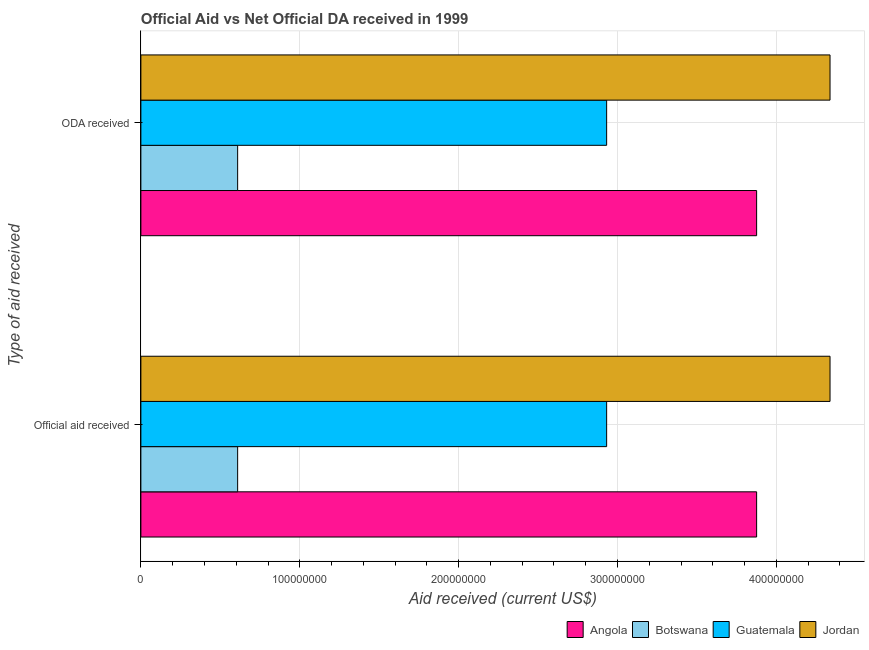How many different coloured bars are there?
Offer a very short reply. 4. How many groups of bars are there?
Make the answer very short. 2. Are the number of bars per tick equal to the number of legend labels?
Offer a terse response. Yes. How many bars are there on the 2nd tick from the top?
Make the answer very short. 4. What is the label of the 1st group of bars from the top?
Offer a very short reply. ODA received. What is the official aid received in Jordan?
Ensure brevity in your answer.  4.34e+08. Across all countries, what is the maximum official aid received?
Your answer should be very brief. 4.34e+08. Across all countries, what is the minimum official aid received?
Offer a terse response. 6.09e+07. In which country was the oda received maximum?
Provide a short and direct response. Jordan. In which country was the official aid received minimum?
Your answer should be very brief. Botswana. What is the total official aid received in the graph?
Keep it short and to the point. 1.18e+09. What is the difference between the oda received in Angola and that in Guatemala?
Your answer should be compact. 9.44e+07. What is the difference between the official aid received in Angola and the oda received in Guatemala?
Your response must be concise. 9.44e+07. What is the average oda received per country?
Your response must be concise. 2.94e+08. What is the difference between the oda received and official aid received in Guatemala?
Give a very brief answer. 0. What is the ratio of the oda received in Guatemala to that in Jordan?
Give a very brief answer. 0.68. Is the official aid received in Angola less than that in Guatemala?
Make the answer very short. No. In how many countries, is the oda received greater than the average oda received taken over all countries?
Provide a succinct answer. 2. What does the 1st bar from the top in ODA received represents?
Offer a very short reply. Jordan. What does the 4th bar from the bottom in Official aid received represents?
Your answer should be very brief. Jordan. How many bars are there?
Ensure brevity in your answer.  8. Are all the bars in the graph horizontal?
Offer a very short reply. Yes. How many countries are there in the graph?
Provide a succinct answer. 4. What is the difference between two consecutive major ticks on the X-axis?
Offer a very short reply. 1.00e+08. Does the graph contain any zero values?
Ensure brevity in your answer.  No. Does the graph contain grids?
Keep it short and to the point. Yes. How are the legend labels stacked?
Make the answer very short. Horizontal. What is the title of the graph?
Ensure brevity in your answer.  Official Aid vs Net Official DA received in 1999 . What is the label or title of the X-axis?
Give a very brief answer. Aid received (current US$). What is the label or title of the Y-axis?
Provide a short and direct response. Type of aid received. What is the Aid received (current US$) in Angola in Official aid received?
Offer a terse response. 3.88e+08. What is the Aid received (current US$) in Botswana in Official aid received?
Offer a terse response. 6.09e+07. What is the Aid received (current US$) in Guatemala in Official aid received?
Offer a terse response. 2.93e+08. What is the Aid received (current US$) of Jordan in Official aid received?
Give a very brief answer. 4.34e+08. What is the Aid received (current US$) in Angola in ODA received?
Provide a succinct answer. 3.88e+08. What is the Aid received (current US$) of Botswana in ODA received?
Your answer should be compact. 6.09e+07. What is the Aid received (current US$) in Guatemala in ODA received?
Make the answer very short. 2.93e+08. What is the Aid received (current US$) in Jordan in ODA received?
Give a very brief answer. 4.34e+08. Across all Type of aid received, what is the maximum Aid received (current US$) of Angola?
Offer a very short reply. 3.88e+08. Across all Type of aid received, what is the maximum Aid received (current US$) of Botswana?
Your answer should be very brief. 6.09e+07. Across all Type of aid received, what is the maximum Aid received (current US$) of Guatemala?
Your answer should be very brief. 2.93e+08. Across all Type of aid received, what is the maximum Aid received (current US$) in Jordan?
Give a very brief answer. 4.34e+08. Across all Type of aid received, what is the minimum Aid received (current US$) of Angola?
Provide a short and direct response. 3.88e+08. Across all Type of aid received, what is the minimum Aid received (current US$) in Botswana?
Your answer should be compact. 6.09e+07. Across all Type of aid received, what is the minimum Aid received (current US$) in Guatemala?
Provide a succinct answer. 2.93e+08. Across all Type of aid received, what is the minimum Aid received (current US$) of Jordan?
Make the answer very short. 4.34e+08. What is the total Aid received (current US$) of Angola in the graph?
Your answer should be very brief. 7.75e+08. What is the total Aid received (current US$) of Botswana in the graph?
Your response must be concise. 1.22e+08. What is the total Aid received (current US$) of Guatemala in the graph?
Provide a succinct answer. 5.86e+08. What is the total Aid received (current US$) in Jordan in the graph?
Give a very brief answer. 8.67e+08. What is the difference between the Aid received (current US$) of Jordan in Official aid received and that in ODA received?
Offer a very short reply. 0. What is the difference between the Aid received (current US$) in Angola in Official aid received and the Aid received (current US$) in Botswana in ODA received?
Provide a short and direct response. 3.27e+08. What is the difference between the Aid received (current US$) of Angola in Official aid received and the Aid received (current US$) of Guatemala in ODA received?
Your answer should be compact. 9.44e+07. What is the difference between the Aid received (current US$) of Angola in Official aid received and the Aid received (current US$) of Jordan in ODA received?
Provide a succinct answer. -4.62e+07. What is the difference between the Aid received (current US$) of Botswana in Official aid received and the Aid received (current US$) of Guatemala in ODA received?
Offer a terse response. -2.32e+08. What is the difference between the Aid received (current US$) in Botswana in Official aid received and the Aid received (current US$) in Jordan in ODA received?
Give a very brief answer. -3.73e+08. What is the difference between the Aid received (current US$) in Guatemala in Official aid received and the Aid received (current US$) in Jordan in ODA received?
Your answer should be compact. -1.41e+08. What is the average Aid received (current US$) in Angola per Type of aid received?
Your answer should be very brief. 3.88e+08. What is the average Aid received (current US$) in Botswana per Type of aid received?
Your answer should be compact. 6.09e+07. What is the average Aid received (current US$) in Guatemala per Type of aid received?
Provide a short and direct response. 2.93e+08. What is the average Aid received (current US$) in Jordan per Type of aid received?
Give a very brief answer. 4.34e+08. What is the difference between the Aid received (current US$) of Angola and Aid received (current US$) of Botswana in Official aid received?
Provide a short and direct response. 3.27e+08. What is the difference between the Aid received (current US$) of Angola and Aid received (current US$) of Guatemala in Official aid received?
Your answer should be very brief. 9.44e+07. What is the difference between the Aid received (current US$) of Angola and Aid received (current US$) of Jordan in Official aid received?
Give a very brief answer. -4.62e+07. What is the difference between the Aid received (current US$) of Botswana and Aid received (current US$) of Guatemala in Official aid received?
Your answer should be compact. -2.32e+08. What is the difference between the Aid received (current US$) of Botswana and Aid received (current US$) of Jordan in Official aid received?
Your answer should be very brief. -3.73e+08. What is the difference between the Aid received (current US$) in Guatemala and Aid received (current US$) in Jordan in Official aid received?
Give a very brief answer. -1.41e+08. What is the difference between the Aid received (current US$) in Angola and Aid received (current US$) in Botswana in ODA received?
Provide a short and direct response. 3.27e+08. What is the difference between the Aid received (current US$) of Angola and Aid received (current US$) of Guatemala in ODA received?
Ensure brevity in your answer.  9.44e+07. What is the difference between the Aid received (current US$) in Angola and Aid received (current US$) in Jordan in ODA received?
Your response must be concise. -4.62e+07. What is the difference between the Aid received (current US$) of Botswana and Aid received (current US$) of Guatemala in ODA received?
Make the answer very short. -2.32e+08. What is the difference between the Aid received (current US$) in Botswana and Aid received (current US$) in Jordan in ODA received?
Keep it short and to the point. -3.73e+08. What is the difference between the Aid received (current US$) of Guatemala and Aid received (current US$) of Jordan in ODA received?
Your answer should be very brief. -1.41e+08. What is the ratio of the Aid received (current US$) in Angola in Official aid received to that in ODA received?
Make the answer very short. 1. What is the ratio of the Aid received (current US$) in Botswana in Official aid received to that in ODA received?
Offer a terse response. 1. What is the difference between the highest and the second highest Aid received (current US$) of Botswana?
Ensure brevity in your answer.  0. What is the difference between the highest and the second highest Aid received (current US$) of Jordan?
Your answer should be very brief. 0. What is the difference between the highest and the lowest Aid received (current US$) in Angola?
Give a very brief answer. 0. What is the difference between the highest and the lowest Aid received (current US$) in Botswana?
Offer a terse response. 0. What is the difference between the highest and the lowest Aid received (current US$) of Jordan?
Provide a short and direct response. 0. 